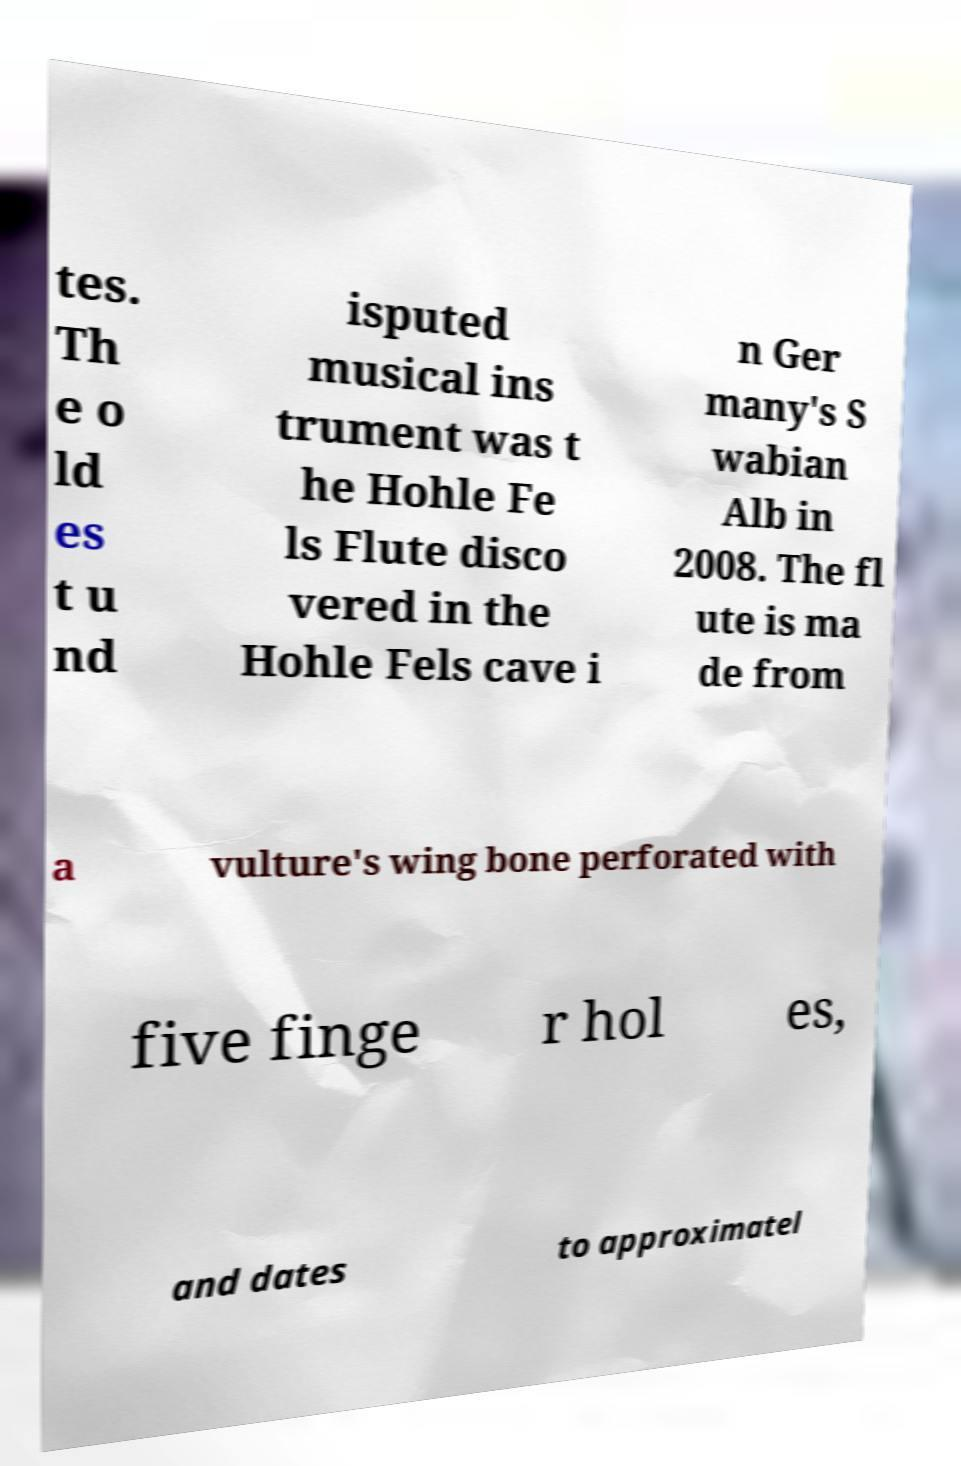Could you extract and type out the text from this image? tes. Th e o ld es t u nd isputed musical ins trument was t he Hohle Fe ls Flute disco vered in the Hohle Fels cave i n Ger many's S wabian Alb in 2008. The fl ute is ma de from a vulture's wing bone perforated with five finge r hol es, and dates to approximatel 